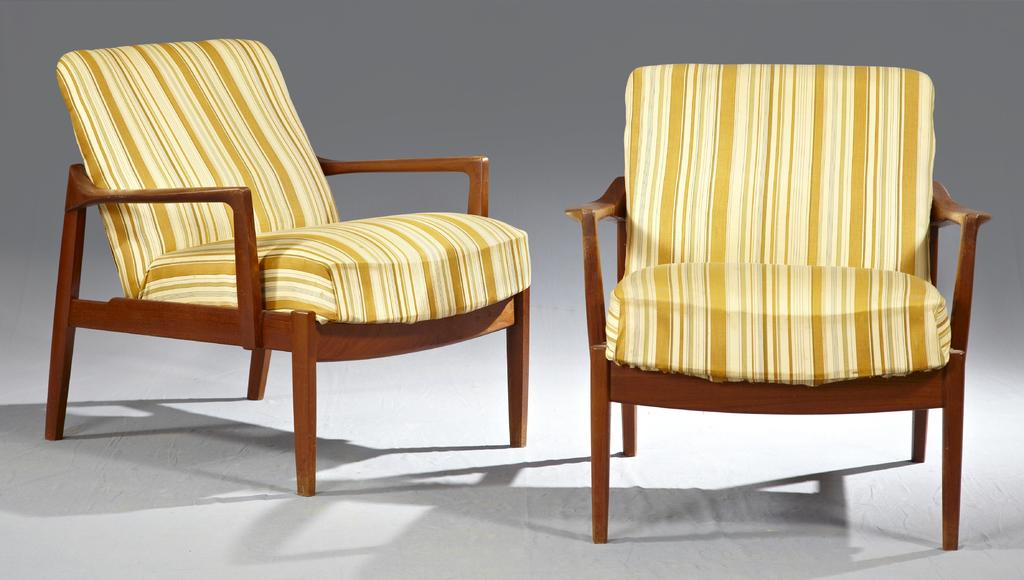How many sofa chairs are in the image? There are two sofa chairs in the image. What color are the sofa chairs? The sofa chairs are yellow in color. What type of garden can be seen in the image? There is no garden present in the image; it only features two yellow sofa chairs. 